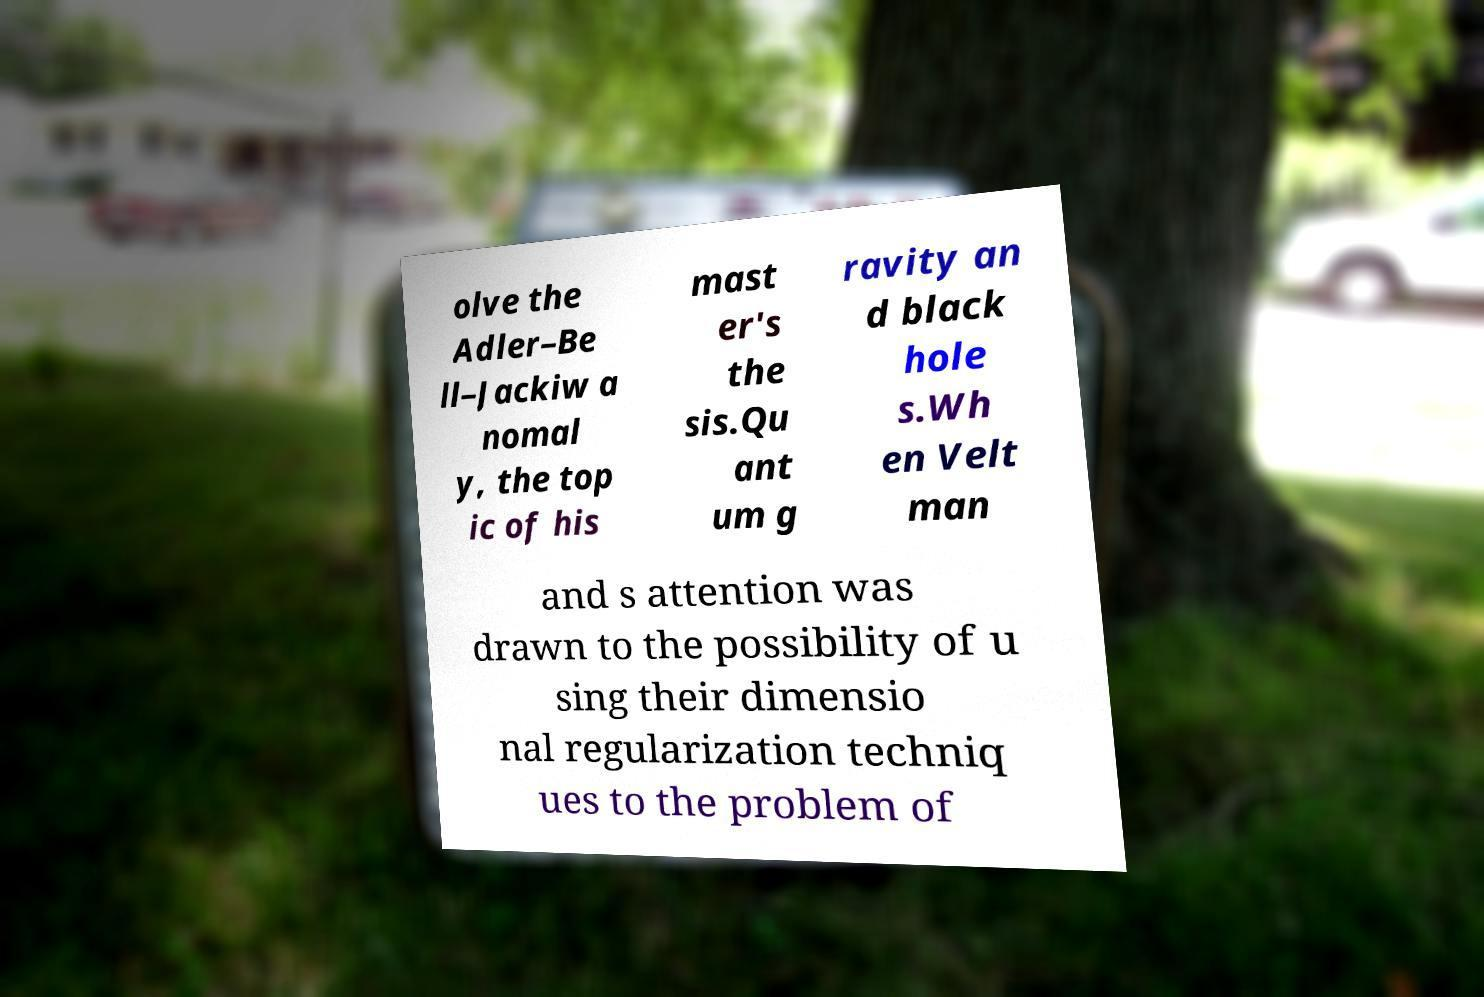Can you accurately transcribe the text from the provided image for me? olve the Adler–Be ll–Jackiw a nomal y, the top ic of his mast er's the sis.Qu ant um g ravity an d black hole s.Wh en Velt man and s attention was drawn to the possibility of u sing their dimensio nal regularization techniq ues to the problem of 